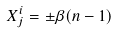<formula> <loc_0><loc_0><loc_500><loc_500>X _ { j } ^ { i } = \pm \beta ( n - 1 ) \,</formula> 